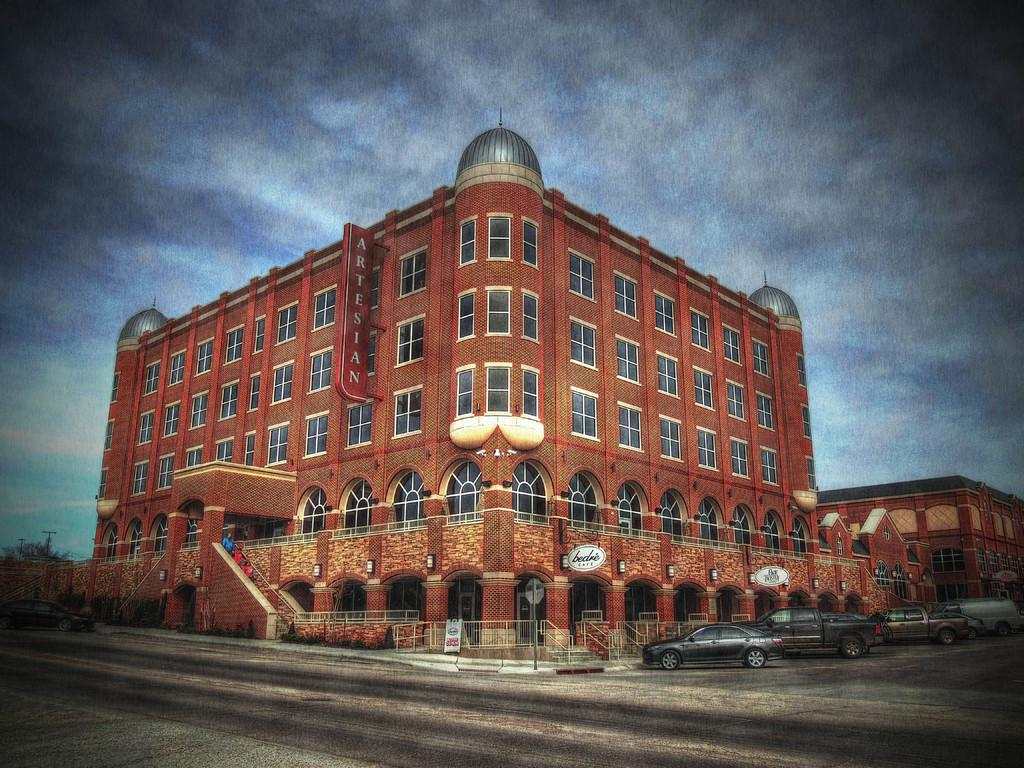What is the main structure in the middle of the image? There is a building in the middle of the image. What can be seen at the top of the image? The sky is visible at the top of the image. What is located at the bottom of the image? There is a road at the bottom of the image. What is parked on the road? There are cars parked on the road. What is beside the parked cars? There is a fence beside the parked cars. Reasoning: Let'g: Let's think step by step in order to produce the conversation. We start by identifying the main structure in the image, which is the building. Then, we describe the sky and the road, which are also visible in the image. Next, we mention the parked cars and the fence beside them, providing more details about the scene. Each question is designed to elicit a specific detail about the image that is known from the provided facts. Absurd Question/Answer: What type of smoke is coming out of the cannon in the image? There is no cannon or smoke present in the image. What flavor of soda is being served at the event in the image? There is no event or soda present in the image. 